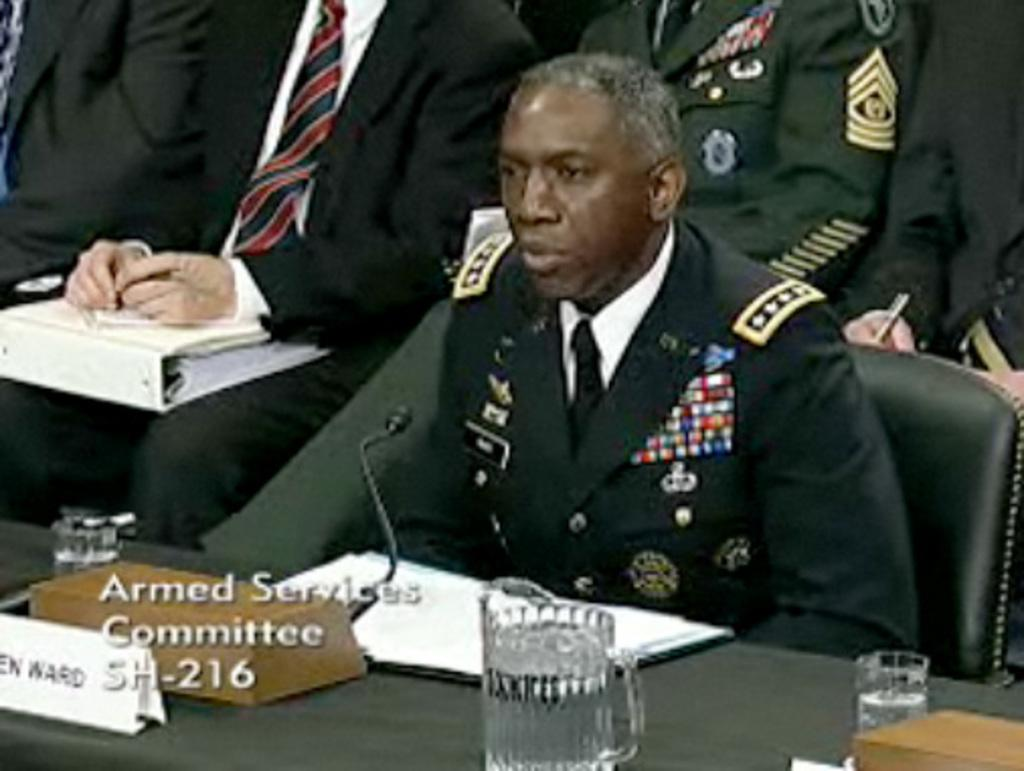How many people are in the image? There is a group of people in the image. What are the people doing in the image? The people are seated on chairs. What objects can be seen on the table in the image? There is a glass, a book, a name board, and a microphone on the table. What type of receipt can be seen on the table in the image? There is no receipt present on the table in the image. 